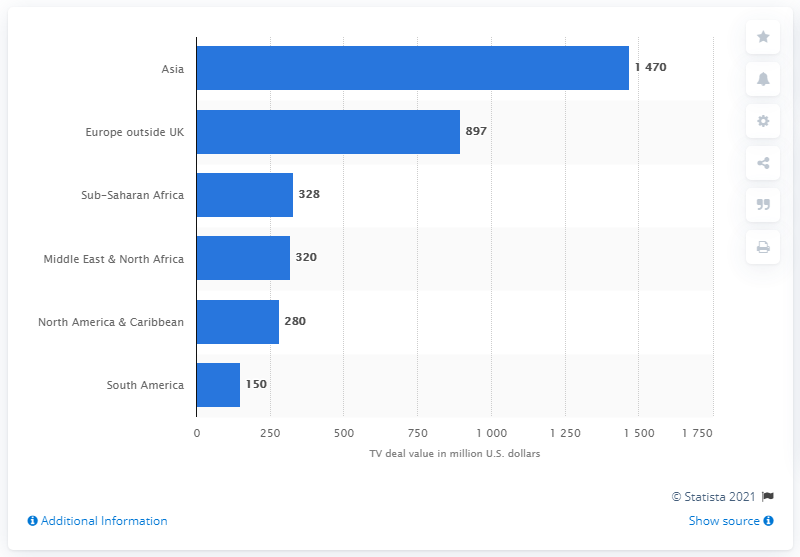Mention a couple of crucial points in this snapshot. The total value of the TV broadcasting deals of the Premier League in Asia is approximately 1470. 